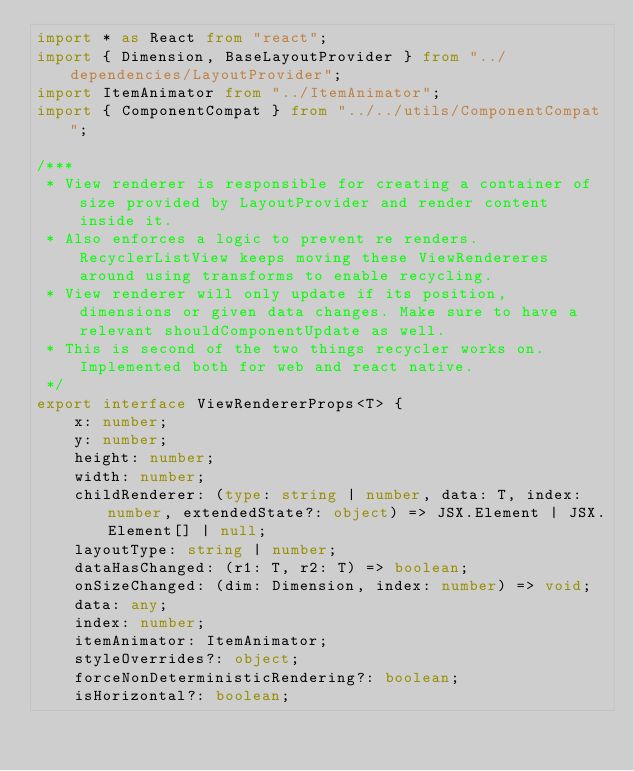Convert code to text. <code><loc_0><loc_0><loc_500><loc_500><_TypeScript_>import * as React from "react";
import { Dimension, BaseLayoutProvider } from "../dependencies/LayoutProvider";
import ItemAnimator from "../ItemAnimator";
import { ComponentCompat } from "../../utils/ComponentCompat";

/***
 * View renderer is responsible for creating a container of size provided by LayoutProvider and render content inside it.
 * Also enforces a logic to prevent re renders. RecyclerListView keeps moving these ViewRendereres around using transforms to enable recycling.
 * View renderer will only update if its position, dimensions or given data changes. Make sure to have a relevant shouldComponentUpdate as well.
 * This is second of the two things recycler works on. Implemented both for web and react native.
 */
export interface ViewRendererProps<T> {
    x: number;
    y: number;
    height: number;
    width: number;
    childRenderer: (type: string | number, data: T, index: number, extendedState?: object) => JSX.Element | JSX.Element[] | null;
    layoutType: string | number;
    dataHasChanged: (r1: T, r2: T) => boolean;
    onSizeChanged: (dim: Dimension, index: number) => void;
    data: any;
    index: number;
    itemAnimator: ItemAnimator;
    styleOverrides?: object;
    forceNonDeterministicRendering?: boolean;
    isHorizontal?: boolean;</code> 